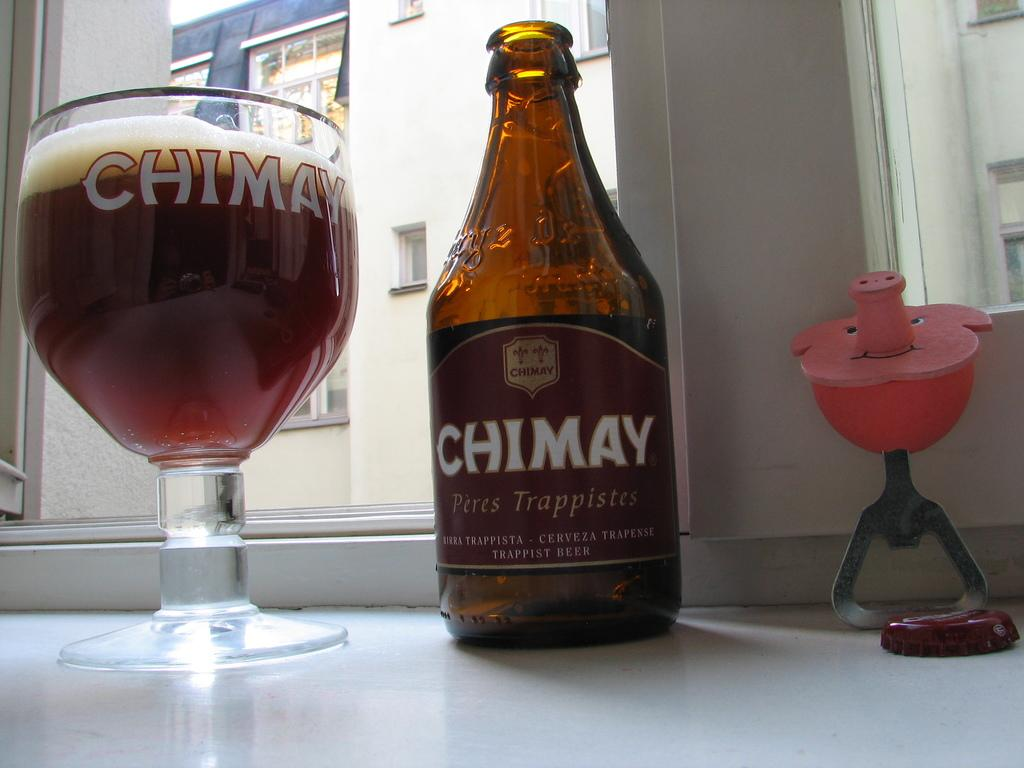<image>
Relay a brief, clear account of the picture shown. A bottle of Chimay sits next to a Chimay glass. 